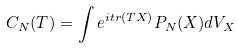Convert formula to latex. <formula><loc_0><loc_0><loc_500><loc_500>C _ { N } ( T ) = \int e ^ { i t r ( T X ) } P _ { N } ( X ) d V _ { X }</formula> 